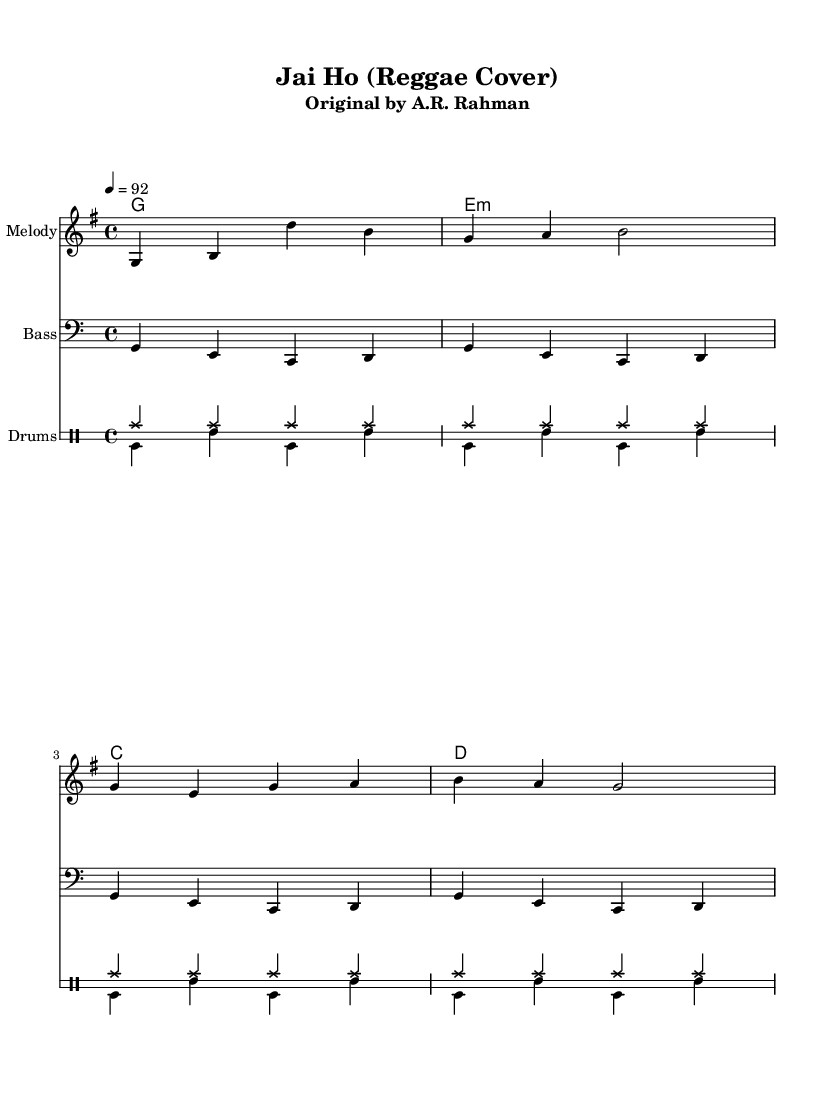What is the key signature of this music? The key signature is G major, which has one sharp (F#). This is identifiable in the piece, as it defines the pitches available in the melody and harmony.
Answer: G major What is the time signature of this music? The time signature is 4/4, indicating that there are four beats per measure and a quarter note receives one beat. This can be determined by the notation at the start of the score.
Answer: 4/4 What is the tempo marking of this music? The tempo marking is 92 beats per minute, indicated by the number below the tempo indication. This tells musicians how quickly to play the piece.
Answer: 92 How many measures are there in the melody? The melody consists of four measures, which can be counted by looking at the vertical lines (bar lines) in the score. Each measure is separated by these lines.
Answer: 4 What type of rhythm is primarily used in the drum section? The primary rhythm in the drum section is a steady eighth-note pattern for the high hats, accompanied by a bass drum and snare in a back-and-forth pattern. This reggae feel is characterized by syncopation and off-beat accents.
Answer: Eighth-note pattern What is the name of the original song? The original song is "Jai Ho," written by A.R. Rahman. This can be deduced from the subtitle of the score, which references the original artist and song title.
Answer: Jai Ho What genre does this cover belong to? This cover belongs to the reggae genre, which can be inferred from the rhythmic style, the use of offbeat strumming in the chords, and the general feel of the arrangement.
Answer: Reggae 